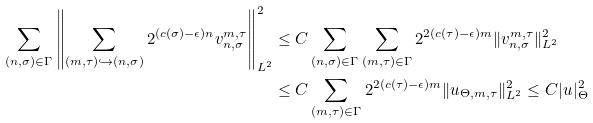Convert formula to latex. <formula><loc_0><loc_0><loc_500><loc_500>\sum _ { ( n , \sigma ) \in \Gamma } \left \| \sum _ { ( m , \tau ) \hookrightarrow ( n , \sigma ) } 2 ^ { ( c ( \sigma ) - \epsilon ) n } v _ { n , \sigma } ^ { m , \tau } \right \| _ { L ^ { 2 } } ^ { 2 } & \leq C \sum _ { ( n , \sigma ) \in \Gamma } \sum _ { ( m , \tau ) \in \Gamma } 2 ^ { 2 ( c ( \tau ) - \epsilon ) m } \| v _ { n , \sigma } ^ { m , \tau } \| _ { L ^ { 2 } } ^ { 2 } \\ & \leq C \sum _ { ( m , \tau ) \in \Gamma } 2 ^ { 2 ( c ( \tau ) - \epsilon ) m } \| u _ { \Theta , m , \tau } \| _ { L ^ { 2 } } ^ { 2 } \leq C | u | _ { \Theta } ^ { 2 }</formula> 